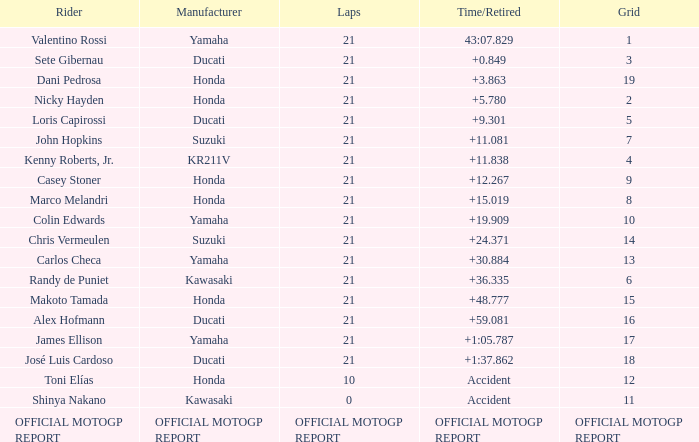When john hopkins completed 21 laps, what was the grid arrangement? 7.0. 